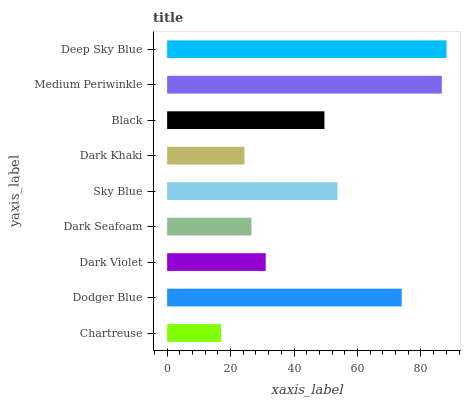Is Chartreuse the minimum?
Answer yes or no. Yes. Is Deep Sky Blue the maximum?
Answer yes or no. Yes. Is Dodger Blue the minimum?
Answer yes or no. No. Is Dodger Blue the maximum?
Answer yes or no. No. Is Dodger Blue greater than Chartreuse?
Answer yes or no. Yes. Is Chartreuse less than Dodger Blue?
Answer yes or no. Yes. Is Chartreuse greater than Dodger Blue?
Answer yes or no. No. Is Dodger Blue less than Chartreuse?
Answer yes or no. No. Is Black the high median?
Answer yes or no. Yes. Is Black the low median?
Answer yes or no. Yes. Is Dark Violet the high median?
Answer yes or no. No. Is Dark Violet the low median?
Answer yes or no. No. 